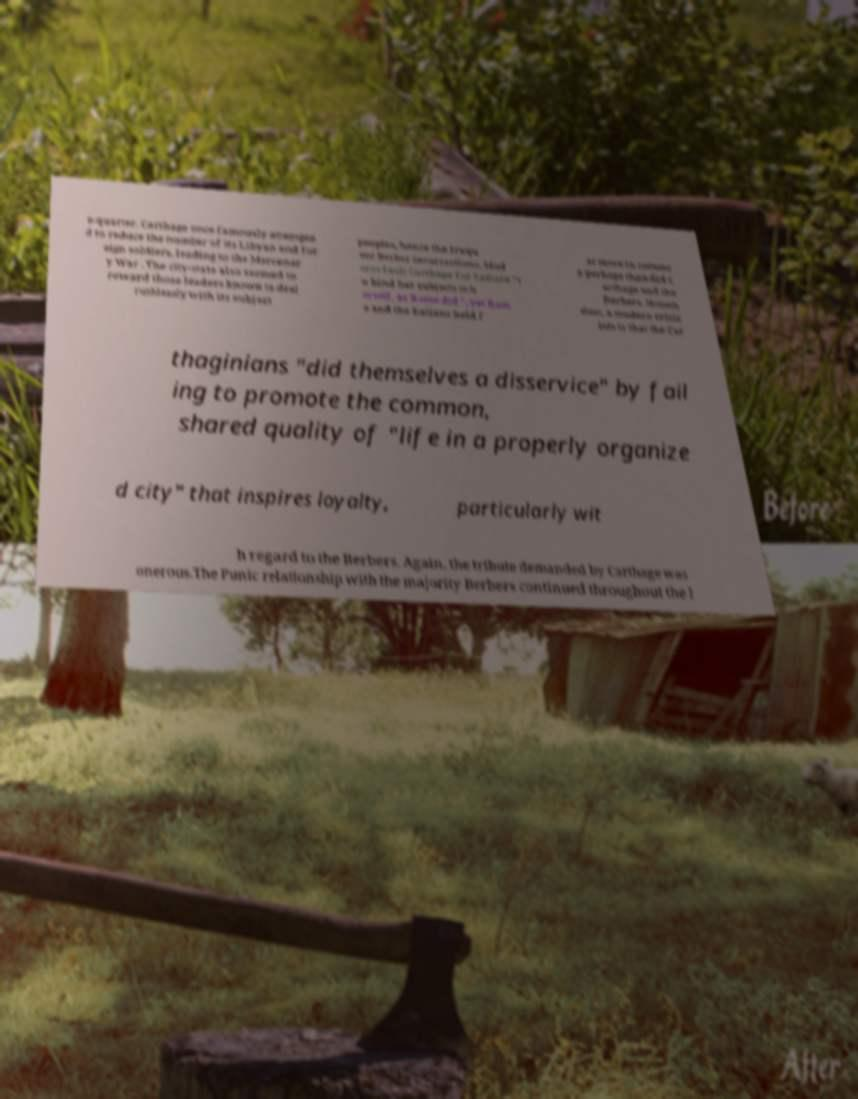Could you extract and type out the text from this image? e-quarter. Carthage once famously attempte d to reduce the number of its Libyan and for eign soldiers, leading to the Mercenar y War . The city-state also seemed to reward those leaders known to deal ruthlessly with its subject peoples, hence the frequ ent Berber insurrections. Mod erns fault Carthage for failure "t o bind her subjects to h erself, as Rome did ", yet Rom e and the Italians held f ar more in commo n perhaps than did C arthage and the Berbers. Noneth eless, a modern critic ism is that the Car thaginians "did themselves a disservice" by fail ing to promote the common, shared quality of "life in a properly organize d city" that inspires loyalty, particularly wit h regard to the Berbers. Again, the tribute demanded by Carthage was onerous.The Punic relationship with the majority Berbers continued throughout the l 